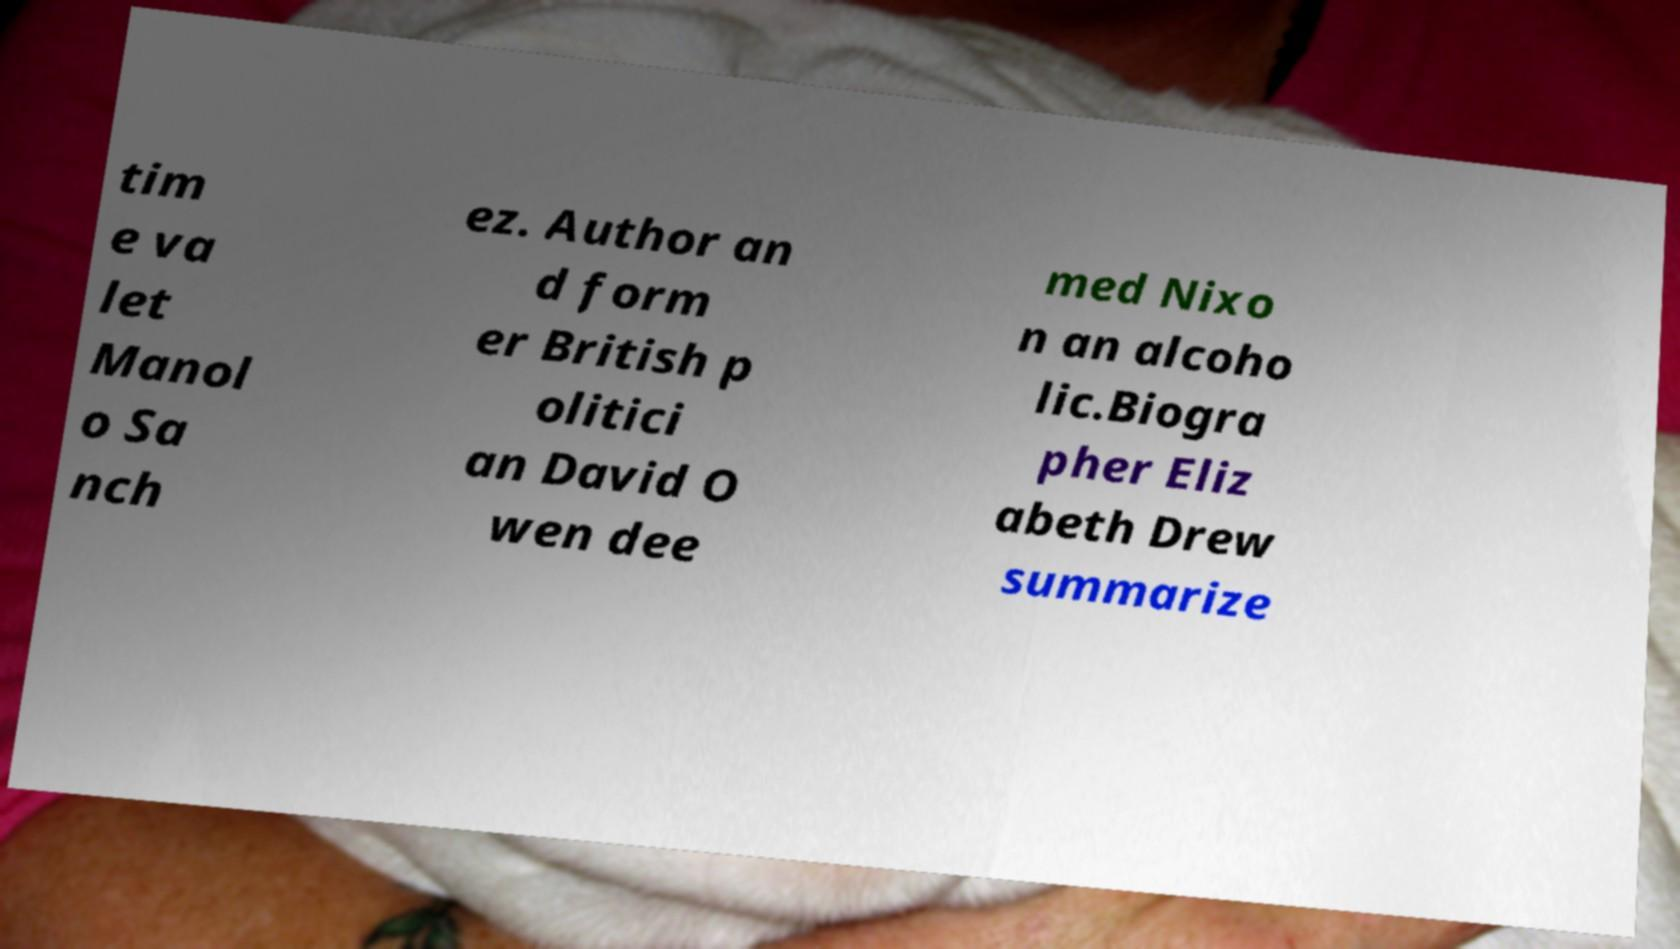What messages or text are displayed in this image? I need them in a readable, typed format. tim e va let Manol o Sa nch ez. Author an d form er British p olitici an David O wen dee med Nixo n an alcoho lic.Biogra pher Eliz abeth Drew summarize 